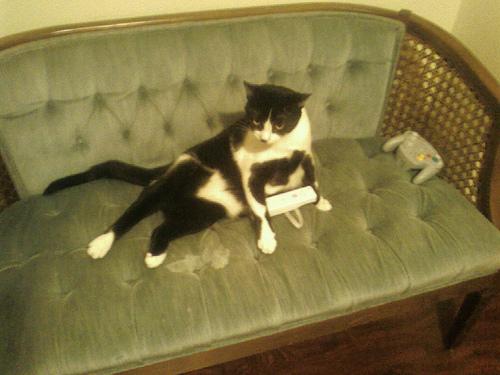Is this a stray cat?
Concise answer only. No. What are the white stains on the furniture?
Answer briefly. Dirt. Can this cat in reality actually play a video game?
Give a very brief answer. No. 